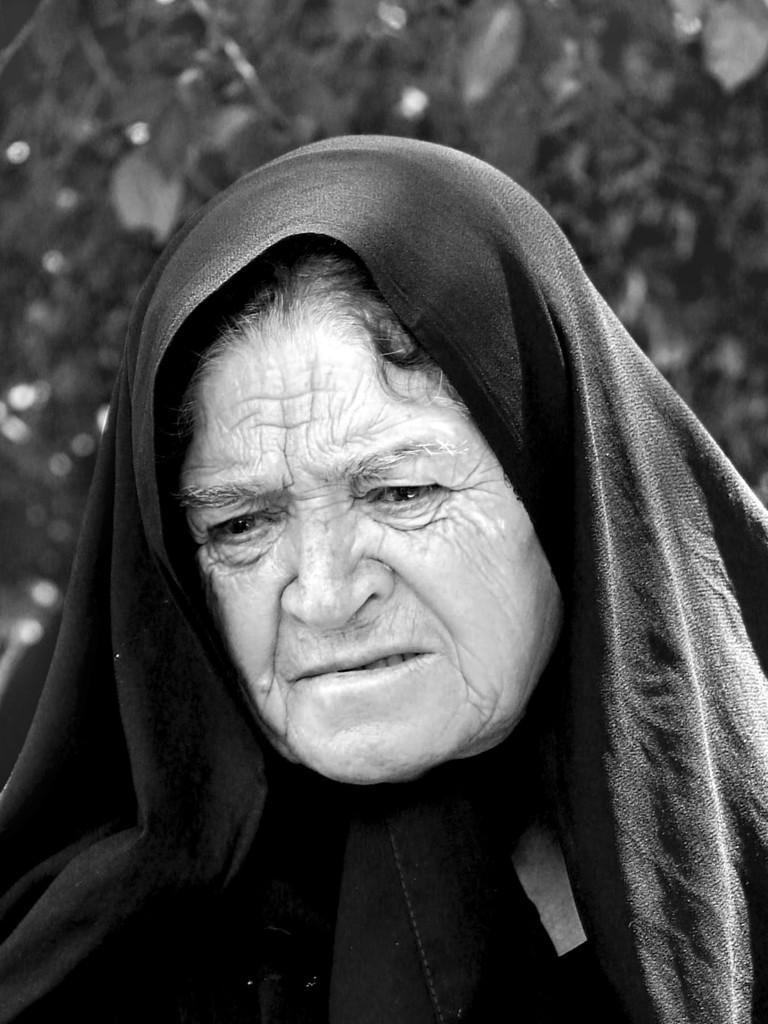Can you describe this image briefly? This picture shows a old woman. She wore a black color cloth on her head and we see trees on the back 